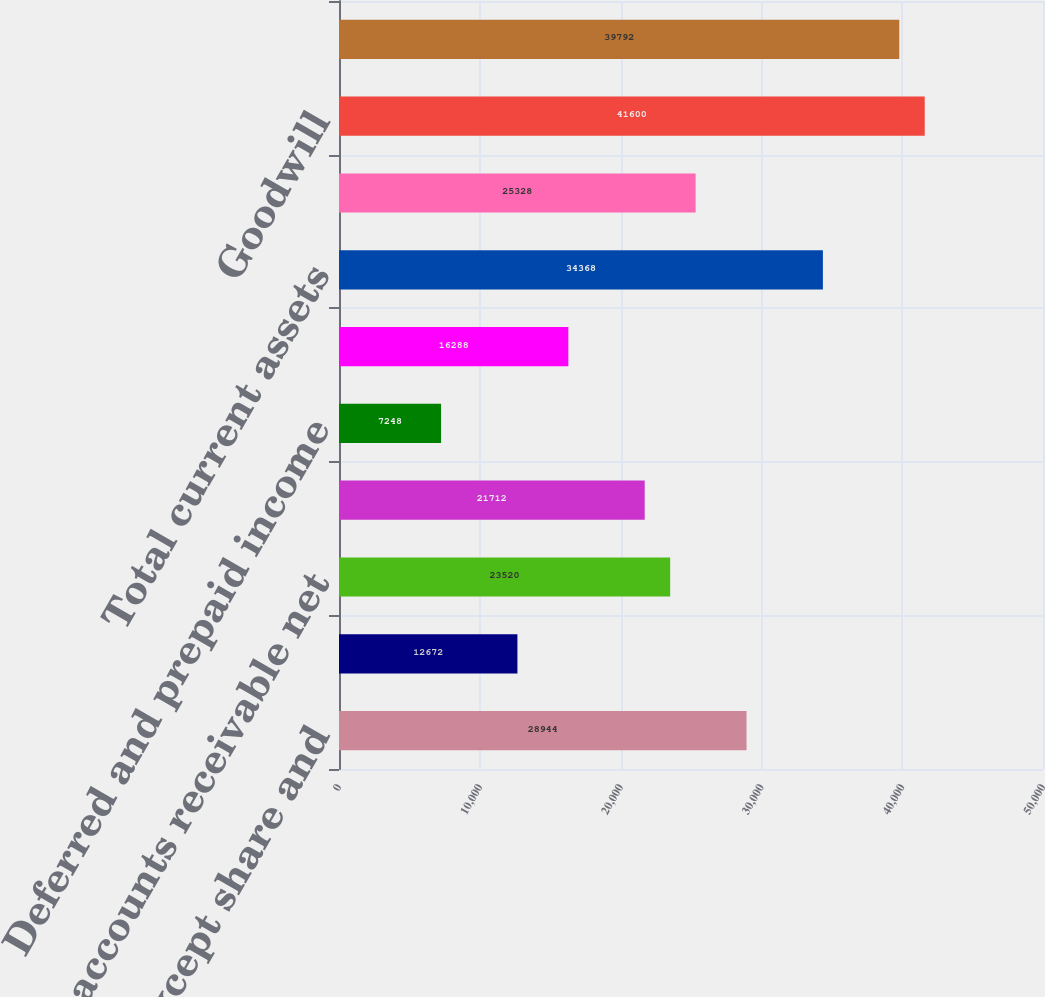Convert chart. <chart><loc_0><loc_0><loc_500><loc_500><bar_chart><fcel>in millions except share and<fcel>Cash and cash equivalents<fcel>Trade accounts receivable net<fcel>Inventories<fcel>Deferred and prepaid income<fcel>Other current assets<fcel>Total current assets<fcel>Property plant and equipment<fcel>Goodwill<fcel>Other intangible assets net<nl><fcel>28944<fcel>12672<fcel>23520<fcel>21712<fcel>7248<fcel>16288<fcel>34368<fcel>25328<fcel>41600<fcel>39792<nl></chart> 